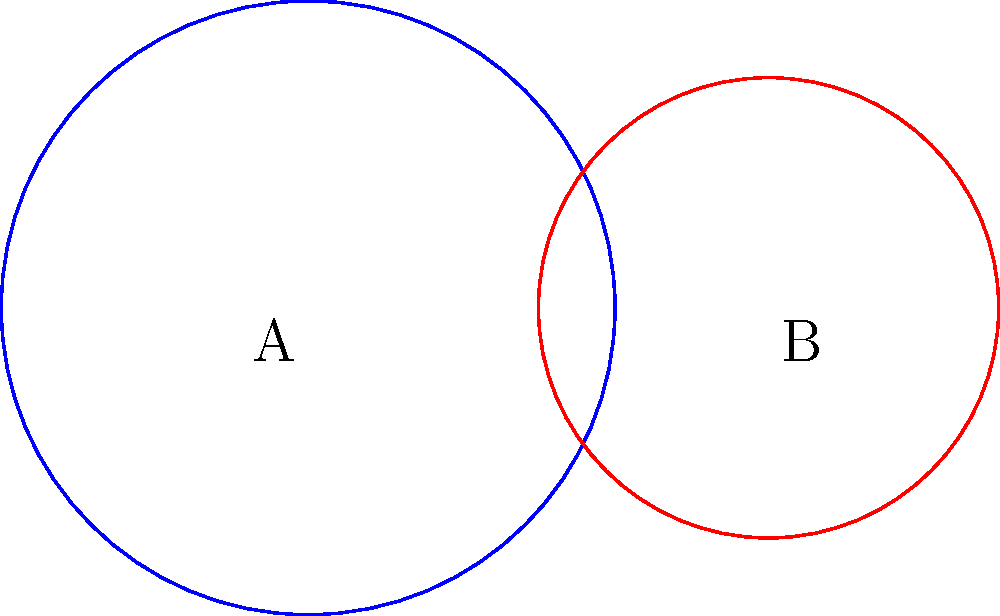In a Buddhist temple in Kathmandu, you observe two overlapping circular mandalas. The larger mandala has a radius of 2 meters, while the smaller one has a radius of 1.5 meters. If the centers of these mandalas are 3 meters apart, what is the area of the overlapping region between the two mandalas? Round your answer to two decimal places. To find the area of the overlapping region, we'll use the formula for the area of intersection of two circles:

1) First, calculate the distance $d$ between the centers of the circles:
   $d = 3$ meters (given in the question)

2) Use the formula for the area of intersection:
   $A = r_1^2 \arccos(\frac{d^2 + r_1^2 - r_2^2}{2dr_1}) + r_2^2 \arccos(\frac{d^2 + r_2^2 - r_1^2}{2dr_2}) - \frac{1}{2}\sqrt{(-d+r_1+r_2)(d+r_1-r_2)(d-r_1+r_2)(d+r_1+r_2)}$

   Where $r_1 = 2$ and $r_2 = 1.5$

3) Substitute the values:
   $A = 2^2 \arccos(\frac{3^2 + 2^2 - 1.5^2}{2 \cdot 3 \cdot 2}) + 1.5^2 \arccos(\frac{3^2 + 1.5^2 - 2^2}{2 \cdot 3 \cdot 1.5}) - \frac{1}{2}\sqrt{(-3+2+1.5)(3+2-1.5)(3-2+1.5)(3+2+1.5)}$

4) Calculate:
   $A \approx 1.2843$ square meters

5) Round to two decimal places:
   $A \approx 1.28$ square meters
Answer: 1.28 m² 